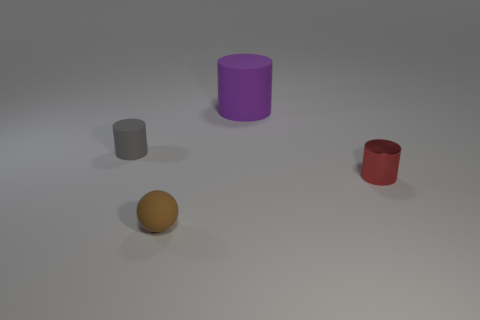Add 4 small shiny cylinders. How many objects exist? 8 Subtract all spheres. How many objects are left? 3 Subtract all large blue metal balls. Subtract all red metal things. How many objects are left? 3 Add 3 purple things. How many purple things are left? 4 Add 1 gray matte objects. How many gray matte objects exist? 2 Subtract 0 blue cylinders. How many objects are left? 4 